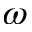<formula> <loc_0><loc_0><loc_500><loc_500>\omega</formula> 